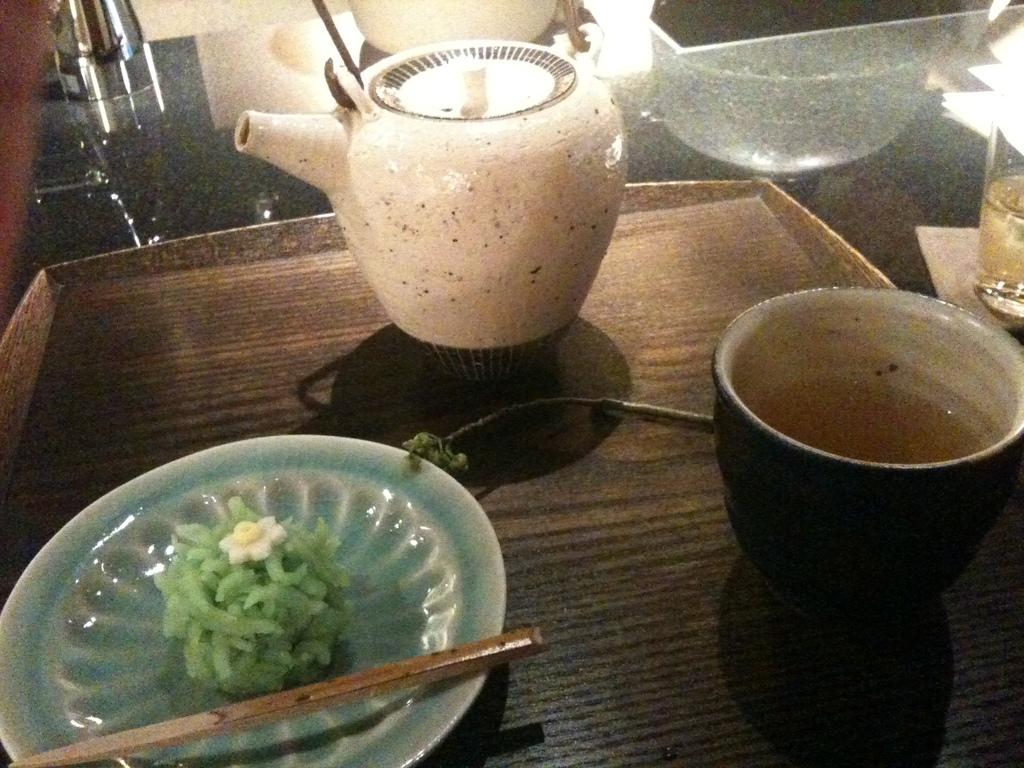What is the main object on the tray in the image? There is a plate on the tray, and it contains food. What other items are on the tray? There is a cup and a kettle on the tray. Where is the tray located in the image? The tray is on a table in the image. What utensil is visible in the image? There is a chopstick in the image. What type of government is depicted in the aftermath of the crate explosion in the image? There is no crate, explosion, or government depicted in the image. The image features a wooden tray with a plate, cup, kettle, table, and chopstick. 